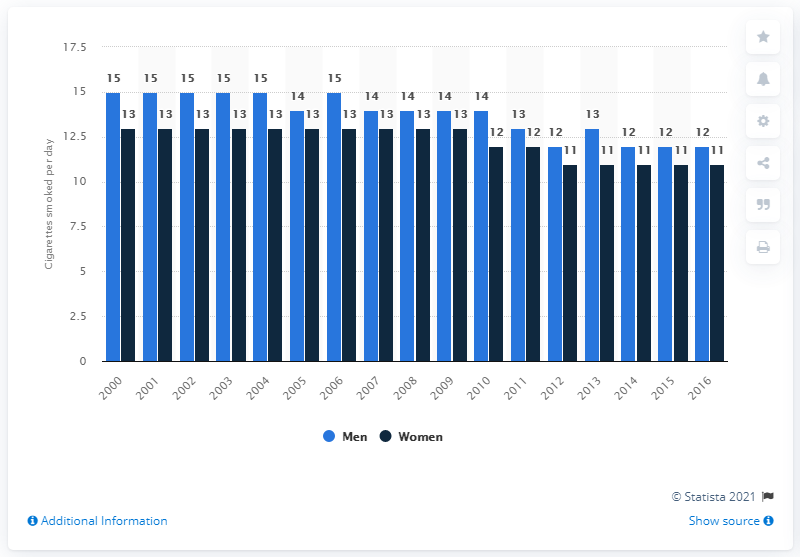Mention a couple of crucial points in this snapshot. In 2017, female smokers on average consumed 11 cigarettes per day. In 2017, male smokers on average consumed 12 cigarettes per day. 